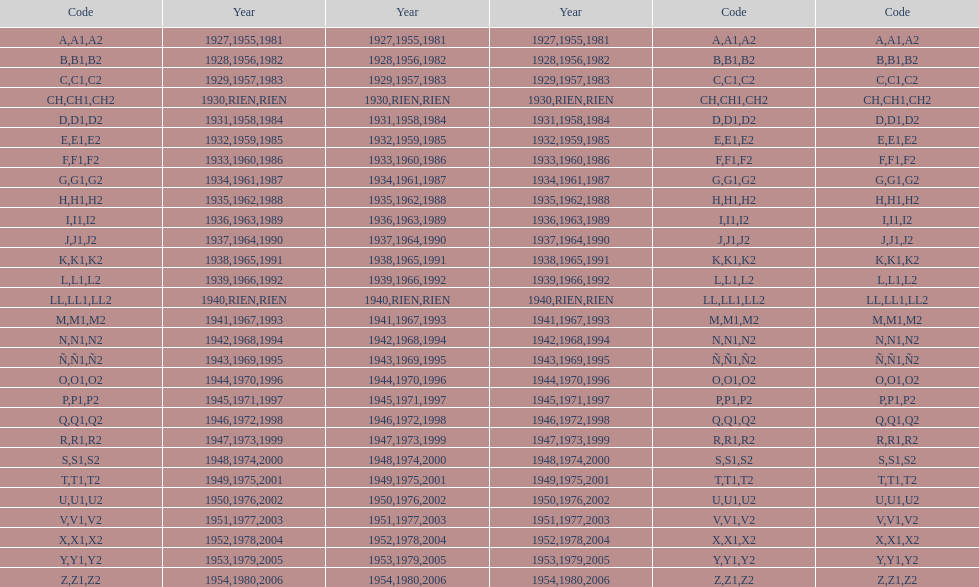Number of codes containing a 2? 28. 